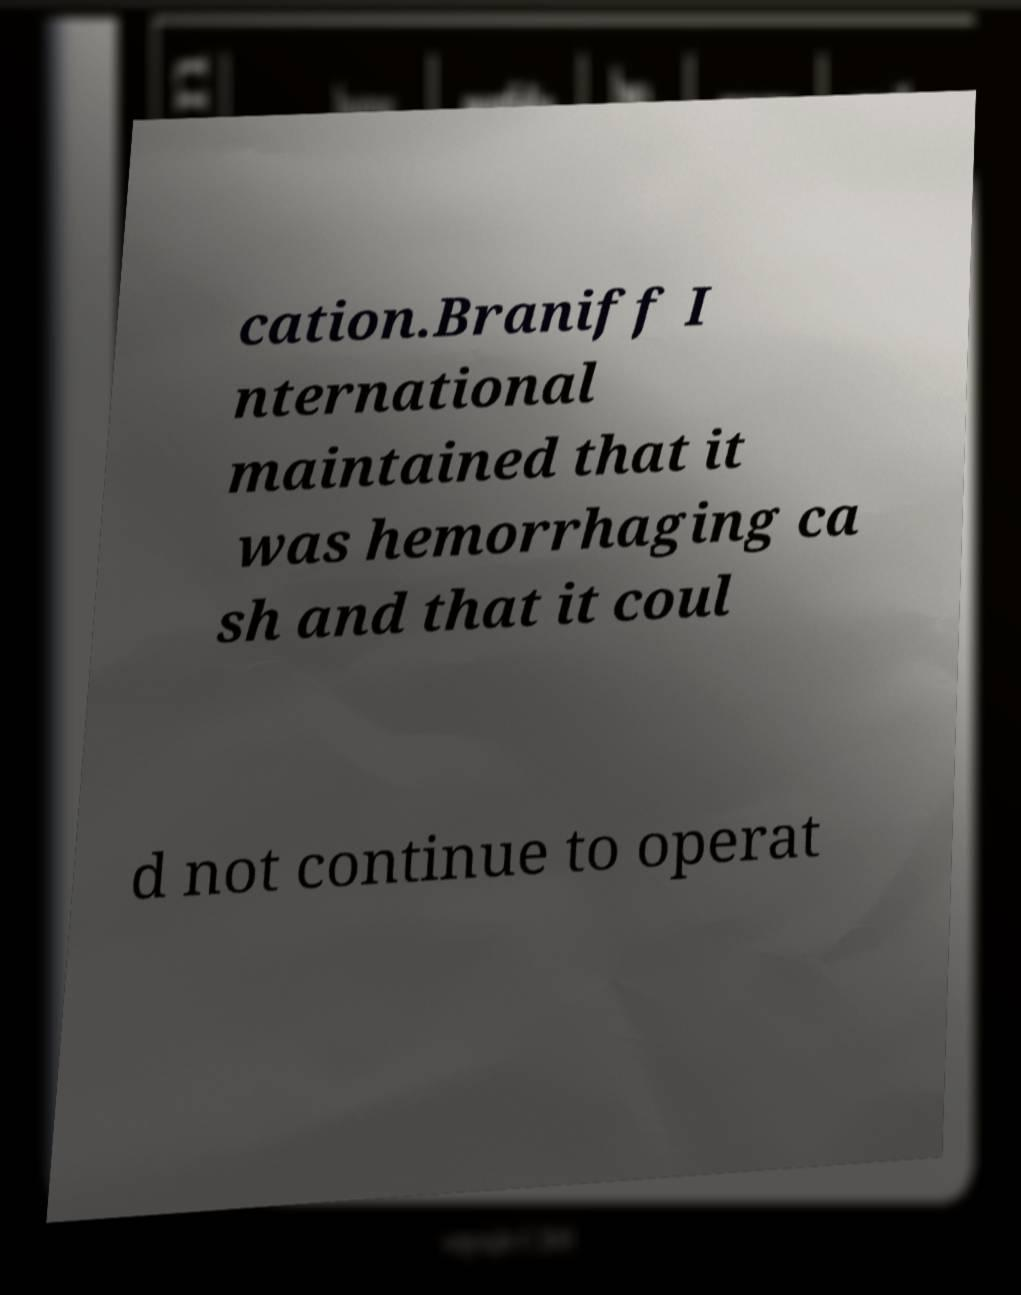For documentation purposes, I need the text within this image transcribed. Could you provide that? cation.Braniff I nternational maintained that it was hemorrhaging ca sh and that it coul d not continue to operat 